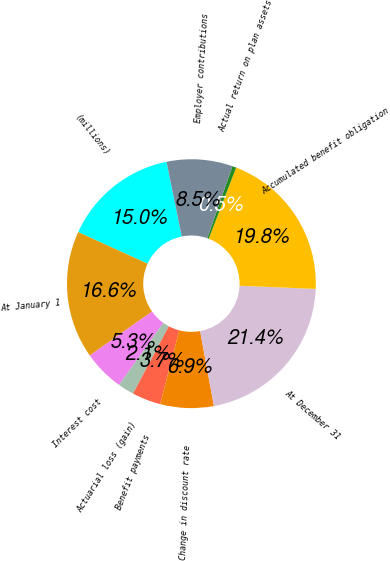Convert chart. <chart><loc_0><loc_0><loc_500><loc_500><pie_chart><fcel>(millions)<fcel>At January 1<fcel>Interest cost<fcel>Actuarial loss (gain)<fcel>Benefit payments<fcel>Change in discount rate<fcel>At December 31<fcel>Accumulated benefit obligation<fcel>Actual return on plan assets<fcel>Employer contributions<nl><fcel>14.99%<fcel>16.6%<fcel>5.33%<fcel>2.11%<fcel>3.72%<fcel>6.94%<fcel>21.43%<fcel>19.82%<fcel>0.51%<fcel>8.55%<nl></chart> 